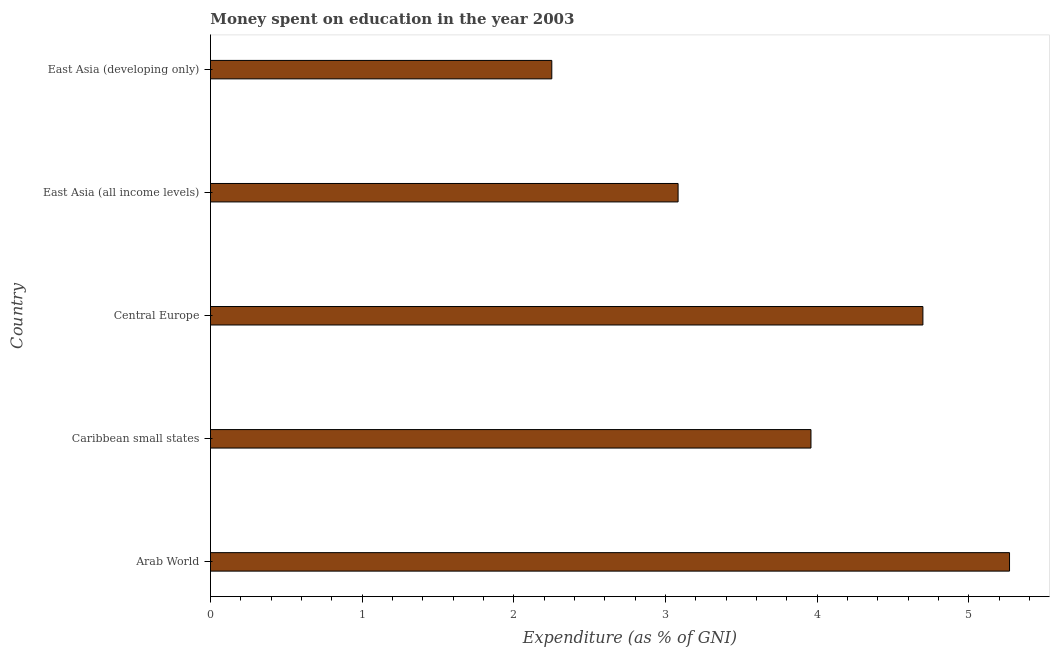Does the graph contain any zero values?
Your answer should be very brief. No. What is the title of the graph?
Provide a short and direct response. Money spent on education in the year 2003. What is the label or title of the X-axis?
Provide a succinct answer. Expenditure (as % of GNI). What is the expenditure on education in East Asia (all income levels)?
Ensure brevity in your answer.  3.08. Across all countries, what is the maximum expenditure on education?
Your answer should be very brief. 5.27. Across all countries, what is the minimum expenditure on education?
Offer a very short reply. 2.25. In which country was the expenditure on education maximum?
Provide a short and direct response. Arab World. In which country was the expenditure on education minimum?
Provide a short and direct response. East Asia (developing only). What is the sum of the expenditure on education?
Provide a succinct answer. 19.25. What is the difference between the expenditure on education in Arab World and East Asia (developing only)?
Your response must be concise. 3.02. What is the average expenditure on education per country?
Provide a short and direct response. 3.85. What is the median expenditure on education?
Make the answer very short. 3.96. In how many countries, is the expenditure on education greater than 2.2 %?
Keep it short and to the point. 5. What is the ratio of the expenditure on education in Caribbean small states to that in East Asia (developing only)?
Your response must be concise. 1.76. Is the difference between the expenditure on education in Arab World and East Asia (all income levels) greater than the difference between any two countries?
Your response must be concise. No. What is the difference between the highest and the second highest expenditure on education?
Ensure brevity in your answer.  0.57. What is the difference between the highest and the lowest expenditure on education?
Provide a short and direct response. 3.02. In how many countries, is the expenditure on education greater than the average expenditure on education taken over all countries?
Offer a terse response. 3. How many bars are there?
Make the answer very short. 5. Are all the bars in the graph horizontal?
Offer a very short reply. Yes. How many countries are there in the graph?
Your answer should be very brief. 5. What is the difference between two consecutive major ticks on the X-axis?
Provide a short and direct response. 1. Are the values on the major ticks of X-axis written in scientific E-notation?
Keep it short and to the point. No. What is the Expenditure (as % of GNI) in Arab World?
Your answer should be compact. 5.27. What is the Expenditure (as % of GNI) of Caribbean small states?
Your answer should be compact. 3.96. What is the Expenditure (as % of GNI) of Central Europe?
Make the answer very short. 4.7. What is the Expenditure (as % of GNI) in East Asia (all income levels)?
Your answer should be very brief. 3.08. What is the Expenditure (as % of GNI) of East Asia (developing only)?
Give a very brief answer. 2.25. What is the difference between the Expenditure (as % of GNI) in Arab World and Caribbean small states?
Make the answer very short. 1.31. What is the difference between the Expenditure (as % of GNI) in Arab World and Central Europe?
Your answer should be very brief. 0.57. What is the difference between the Expenditure (as % of GNI) in Arab World and East Asia (all income levels)?
Your answer should be very brief. 2.18. What is the difference between the Expenditure (as % of GNI) in Arab World and East Asia (developing only)?
Your answer should be very brief. 3.02. What is the difference between the Expenditure (as % of GNI) in Caribbean small states and Central Europe?
Your answer should be compact. -0.74. What is the difference between the Expenditure (as % of GNI) in Caribbean small states and East Asia (all income levels)?
Offer a very short reply. 0.88. What is the difference between the Expenditure (as % of GNI) in Caribbean small states and East Asia (developing only)?
Give a very brief answer. 1.71. What is the difference between the Expenditure (as % of GNI) in Central Europe and East Asia (all income levels)?
Give a very brief answer. 1.61. What is the difference between the Expenditure (as % of GNI) in Central Europe and East Asia (developing only)?
Give a very brief answer. 2.45. What is the difference between the Expenditure (as % of GNI) in East Asia (all income levels) and East Asia (developing only)?
Make the answer very short. 0.83. What is the ratio of the Expenditure (as % of GNI) in Arab World to that in Caribbean small states?
Provide a succinct answer. 1.33. What is the ratio of the Expenditure (as % of GNI) in Arab World to that in Central Europe?
Your answer should be very brief. 1.12. What is the ratio of the Expenditure (as % of GNI) in Arab World to that in East Asia (all income levels)?
Give a very brief answer. 1.71. What is the ratio of the Expenditure (as % of GNI) in Arab World to that in East Asia (developing only)?
Offer a very short reply. 2.34. What is the ratio of the Expenditure (as % of GNI) in Caribbean small states to that in Central Europe?
Make the answer very short. 0.84. What is the ratio of the Expenditure (as % of GNI) in Caribbean small states to that in East Asia (all income levels)?
Make the answer very short. 1.28. What is the ratio of the Expenditure (as % of GNI) in Caribbean small states to that in East Asia (developing only)?
Make the answer very short. 1.76. What is the ratio of the Expenditure (as % of GNI) in Central Europe to that in East Asia (all income levels)?
Provide a succinct answer. 1.52. What is the ratio of the Expenditure (as % of GNI) in Central Europe to that in East Asia (developing only)?
Keep it short and to the point. 2.09. What is the ratio of the Expenditure (as % of GNI) in East Asia (all income levels) to that in East Asia (developing only)?
Make the answer very short. 1.37. 